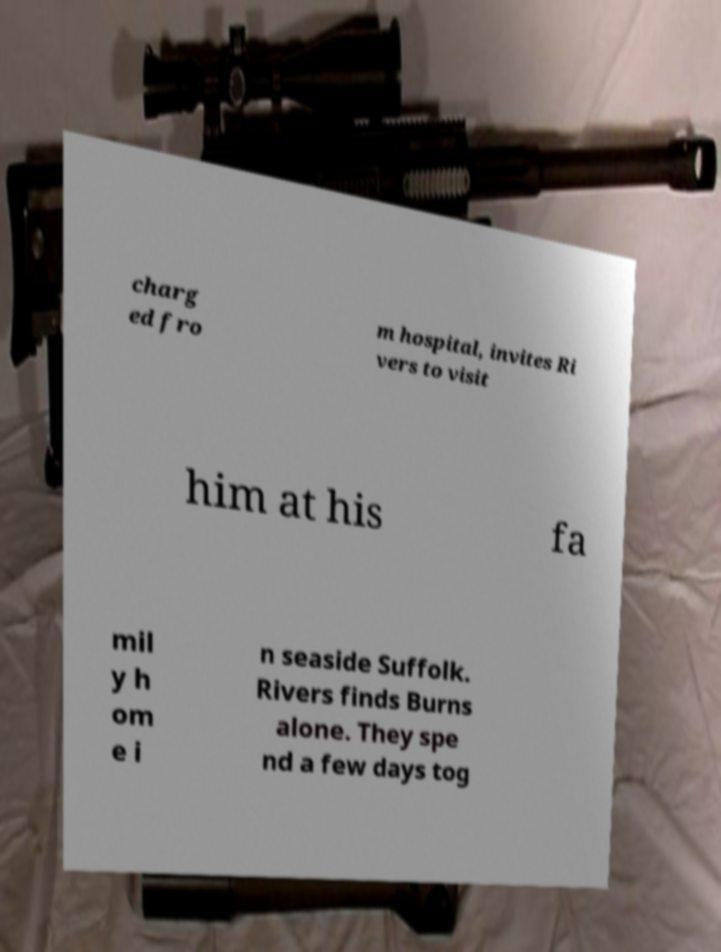Please read and relay the text visible in this image. What does it say? charg ed fro m hospital, invites Ri vers to visit him at his fa mil y h om e i n seaside Suffolk. Rivers finds Burns alone. They spe nd a few days tog 